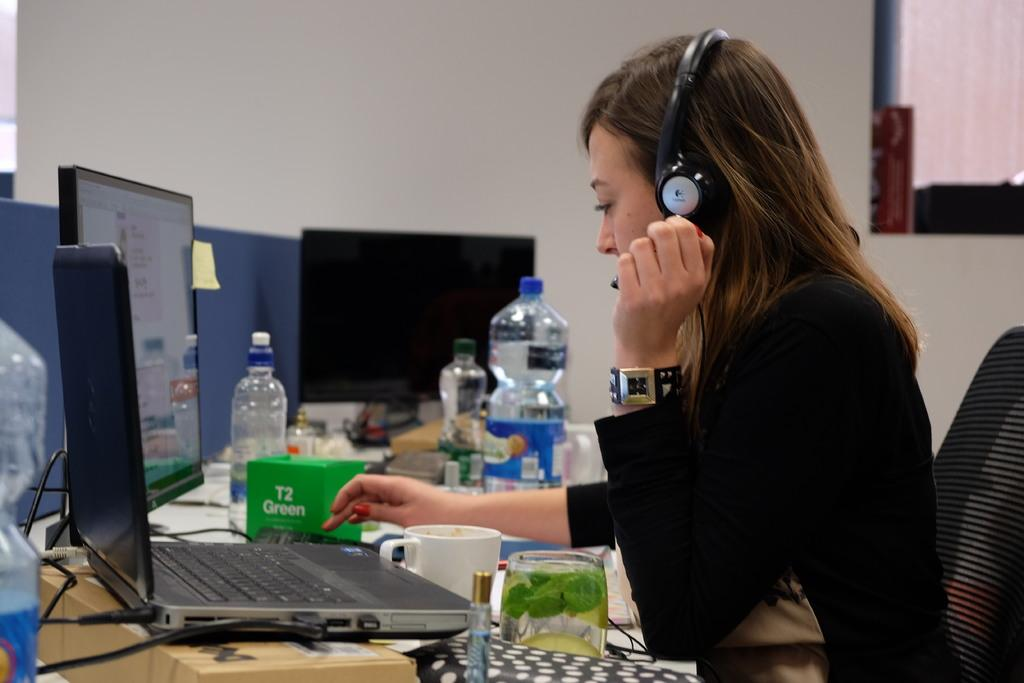Provide a one-sentence caption for the provided image. A woman types on her laptop next to a green box that says T2 Green. 